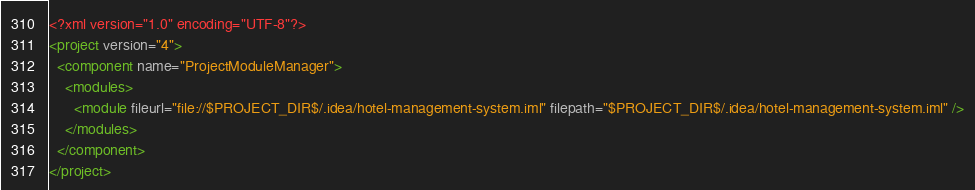<code> <loc_0><loc_0><loc_500><loc_500><_XML_><?xml version="1.0" encoding="UTF-8"?>
<project version="4">
  <component name="ProjectModuleManager">
    <modules>
      <module fileurl="file://$PROJECT_DIR$/.idea/hotel-management-system.iml" filepath="$PROJECT_DIR$/.idea/hotel-management-system.iml" />
    </modules>
  </component>
</project></code> 